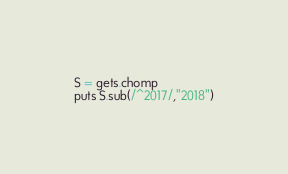Convert code to text. <code><loc_0><loc_0><loc_500><loc_500><_Ruby_>S = gets.chomp
puts S.sub(/^2017/,"2018")</code> 